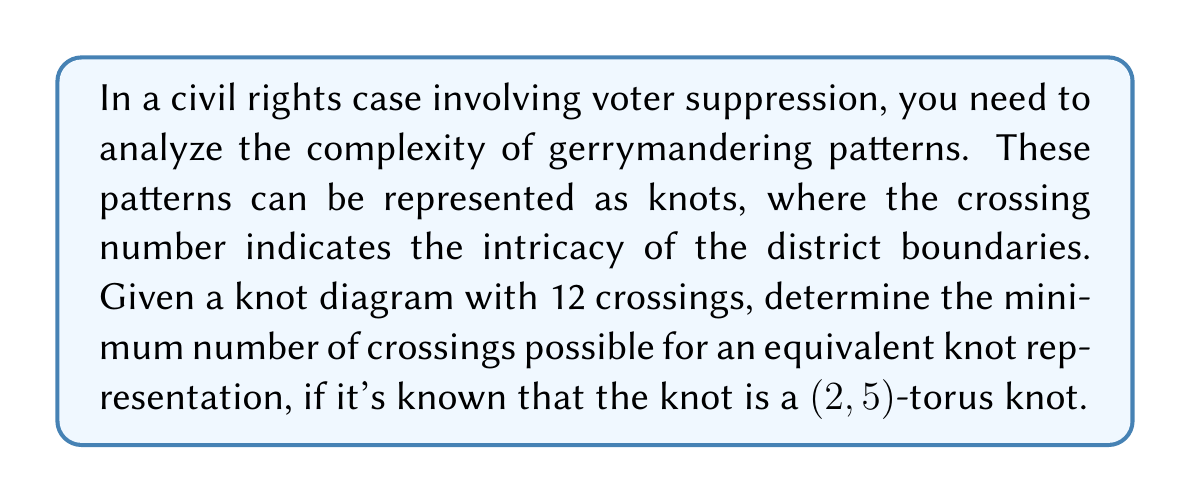Can you answer this question? To solve this problem, we'll follow these steps:

1) First, recall that a (p,q)-torus knot is formed by wrapping a curve p times around a torus in one direction and q times in the other direction, where p and q are coprime integers.

2) For a (p,q)-torus knot, the crossing number is given by the formula:

   $$c(T_{p,q}) = \min(p(q-1), q(p-1))$$

3) In our case, we have a (2,5)-torus knot. Let's apply the formula:

   $$c(T_{2,5}) = \min(2(5-1), 5(2-1))$$
   $$c(T_{2,5}) = \min(2(4), 5(1))$$
   $$c(T_{2,5}) = \min(8, 5)$$

4) The minimum of 8 and 5 is 5.

5) Therefore, the minimum crossing number for a (2,5)-torus knot is 5.

6) This means that although the given knot diagram has 12 crossings, it can be simplified to an equivalent representation with only 5 crossings.
Answer: 5 